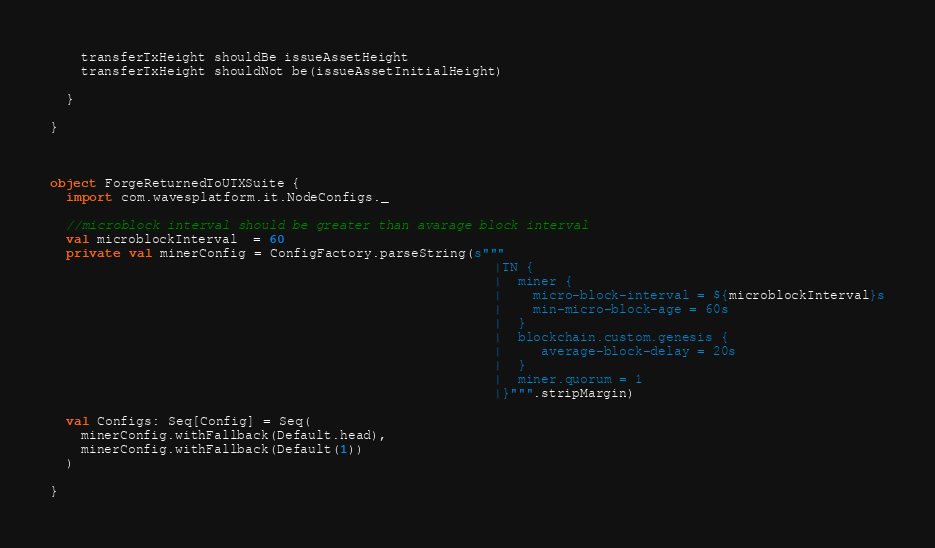Convert code to text. <code><loc_0><loc_0><loc_500><loc_500><_Scala_>    transferTxHeight shouldBe issueAssetHeight
    transferTxHeight shouldNot be(issueAssetInitialHeight)

  }

}



object ForgeReturnedToUTXSuite {
  import com.wavesplatform.it.NodeConfigs._

  //microblock interval should be greater than avarage block interval
  val microblockInterval  = 60
  private val minerConfig = ConfigFactory.parseString(s"""
                                                         |TN {
                                                         |  miner {
                                                         |    micro-block-interval = ${microblockInterval}s
                                                         |    min-micro-block-age = 60s
                                                         |  }
                                                         |  blockchain.custom.genesis {
                                                         |     average-block-delay = 20s
                                                         |  }
                                                         |  miner.quorum = 1
                                                         |}""".stripMargin)

  val Configs: Seq[Config] = Seq(
    minerConfig.withFallback(Default.head),
    minerConfig.withFallback(Default(1))
  )

}
</code> 